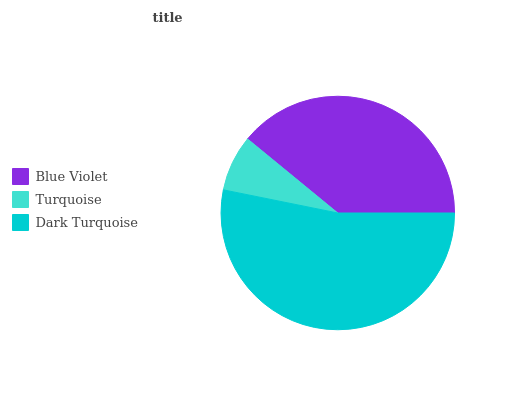Is Turquoise the minimum?
Answer yes or no. Yes. Is Dark Turquoise the maximum?
Answer yes or no. Yes. Is Dark Turquoise the minimum?
Answer yes or no. No. Is Turquoise the maximum?
Answer yes or no. No. Is Dark Turquoise greater than Turquoise?
Answer yes or no. Yes. Is Turquoise less than Dark Turquoise?
Answer yes or no. Yes. Is Turquoise greater than Dark Turquoise?
Answer yes or no. No. Is Dark Turquoise less than Turquoise?
Answer yes or no. No. Is Blue Violet the high median?
Answer yes or no. Yes. Is Blue Violet the low median?
Answer yes or no. Yes. Is Turquoise the high median?
Answer yes or no. No. Is Turquoise the low median?
Answer yes or no. No. 